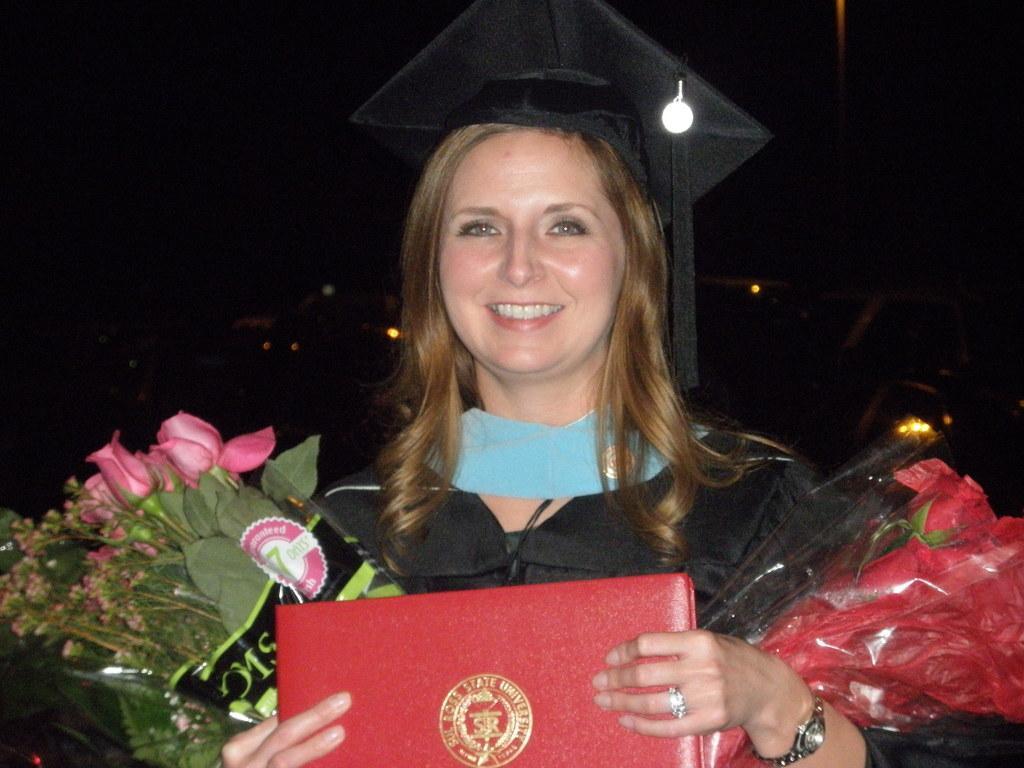Can you describe this image briefly? In this image, we can see a person wearing clothes and hat. This person is holding a file and bouquets. 